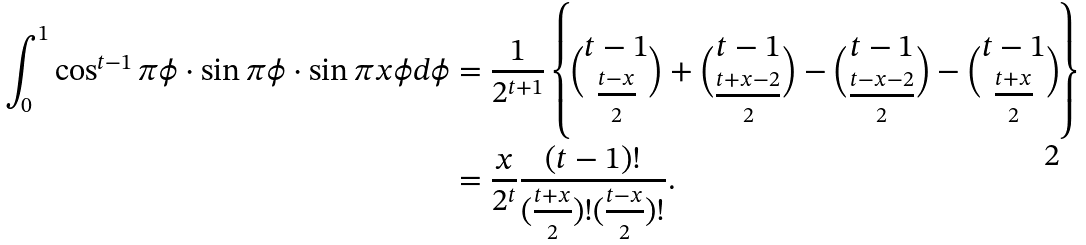Convert formula to latex. <formula><loc_0><loc_0><loc_500><loc_500>\int _ { 0 } ^ { 1 } \cos ^ { t - 1 } \pi \phi \cdot \sin \pi \phi \cdot \sin \pi x \phi d \phi & = \frac { 1 } { 2 ^ { t + 1 } } \left \{ \binom { t - 1 } { \frac { t - x } { 2 } } + \binom { t - 1 } { \frac { t + x - 2 } { 2 } } - \binom { t - 1 } { \frac { t - x - 2 } { 2 } } - \binom { t - 1 } { \frac { t + x } { 2 } } \right \} \\ & = \frac { x } { 2 ^ { t } } \frac { ( t - 1 ) ! } { ( \frac { t + x } { 2 } ) ! ( \frac { t - x } { 2 } ) ! } .</formula> 